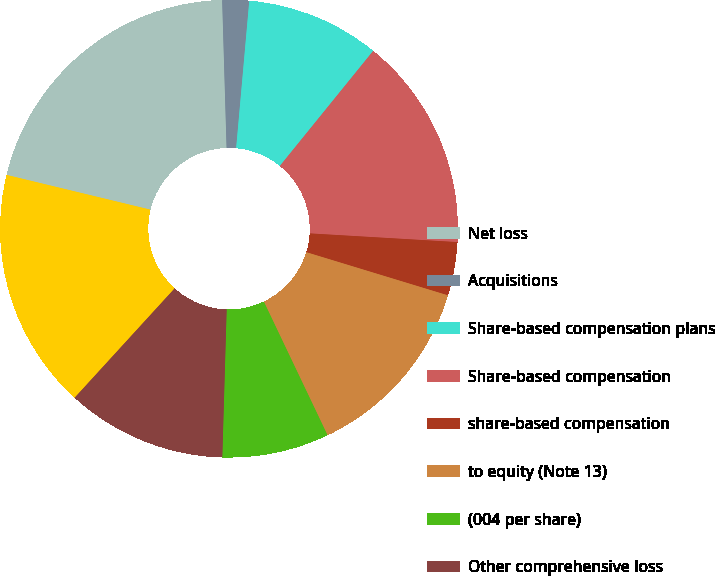Convert chart to OTSL. <chart><loc_0><loc_0><loc_500><loc_500><pie_chart><fcel>Net loss<fcel>Acquisitions<fcel>Share-based compensation plans<fcel>Share-based compensation<fcel>share-based compensation<fcel>to equity (Note 13)<fcel>(004 per share)<fcel>Other comprehensive loss<fcel>Other<fcel>Net earnings<nl><fcel>20.75%<fcel>1.89%<fcel>9.43%<fcel>15.09%<fcel>3.77%<fcel>13.21%<fcel>7.55%<fcel>11.32%<fcel>0.0%<fcel>16.98%<nl></chart> 